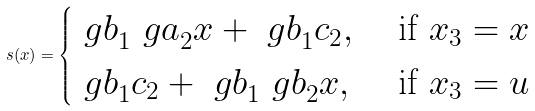Convert formula to latex. <formula><loc_0><loc_0><loc_500><loc_500>s ( x ) = \begin{cases} { \ g b } _ { 1 } { \ g a } _ { 2 } x + { \ g b } _ { 1 } c _ { 2 } , & \text { if } x _ { 3 } = x \\ { \ g b } _ { 1 } c _ { 2 } + { \ g b } _ { 1 } { \ g b } _ { 2 } x , & \text { if } x _ { 3 } = u \end{cases}</formula> 